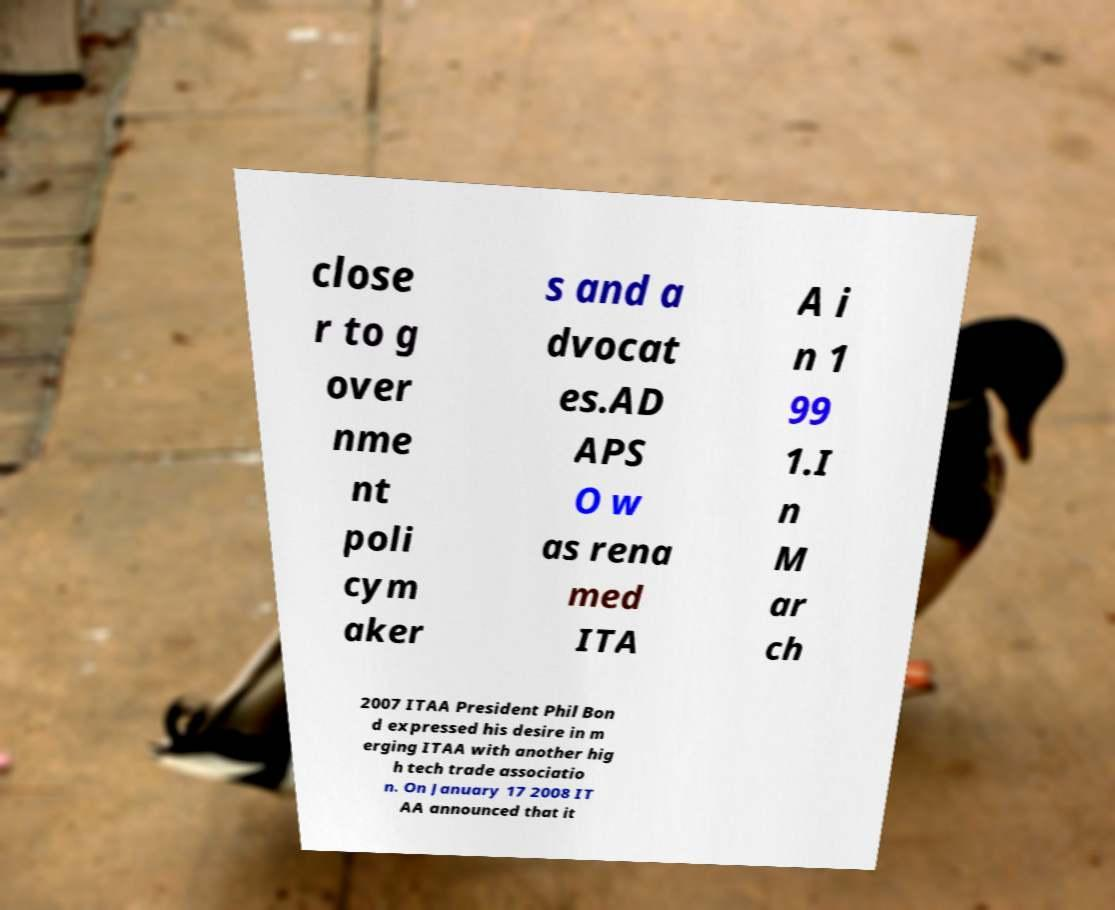For documentation purposes, I need the text within this image transcribed. Could you provide that? close r to g over nme nt poli cym aker s and a dvocat es.AD APS O w as rena med ITA A i n 1 99 1.I n M ar ch 2007 ITAA President Phil Bon d expressed his desire in m erging ITAA with another hig h tech trade associatio n. On January 17 2008 IT AA announced that it 